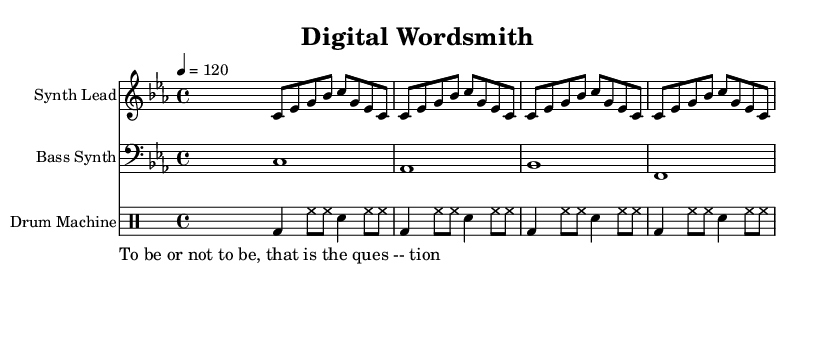What is the key signature of this composition? The key signature is indicated by the number of sharps or flats following the clef at the beginning of the staff. In this composition, there are three flats, which corresponds to C minor.
Answer: C minor What is the time signature of the piece? The time signature is noted next to the key signature at the beginning of the score. It shows a "4/4" time signature, indicating four beats per measure.
Answer: 4/4 What is the tempo marking of this music? The tempo marking indicated above the staff shows the speed of the music. In this case, "4 = 120" means there are 120 beats per minute, indicating a moderate tempo.
Answer: 120 How many bars are in the synth lead section? By counting the groupings of notes and looking for the end of a musical phrase or measure, it is noticeable that the synth lead section consists of four measures.
Answer: 4 Which literary quote is incorporated into the music? The text provided in the lyric mode contains a well-known quote. Reading the lyrics section reveals it is "To be or not to be, that is the question."
Answer: To be or not to be, that is the question What is the rhythmic pattern of the drum machine? The rhythmic pattern can be identified by observing the sequence of note types in the drum mode section; in this case, it consists of a repetitive pattern of bass drum and hi-hat notes.
Answer: bass drum and hi-hat What type of instruments are used in this composition? Looking at the different staves in the score and their labels, the instruments listed are a synthesizer lead, bass synth, and a drum machine for rhythm.
Answer: Synth Lead, Bass Synth, Drum Machine 